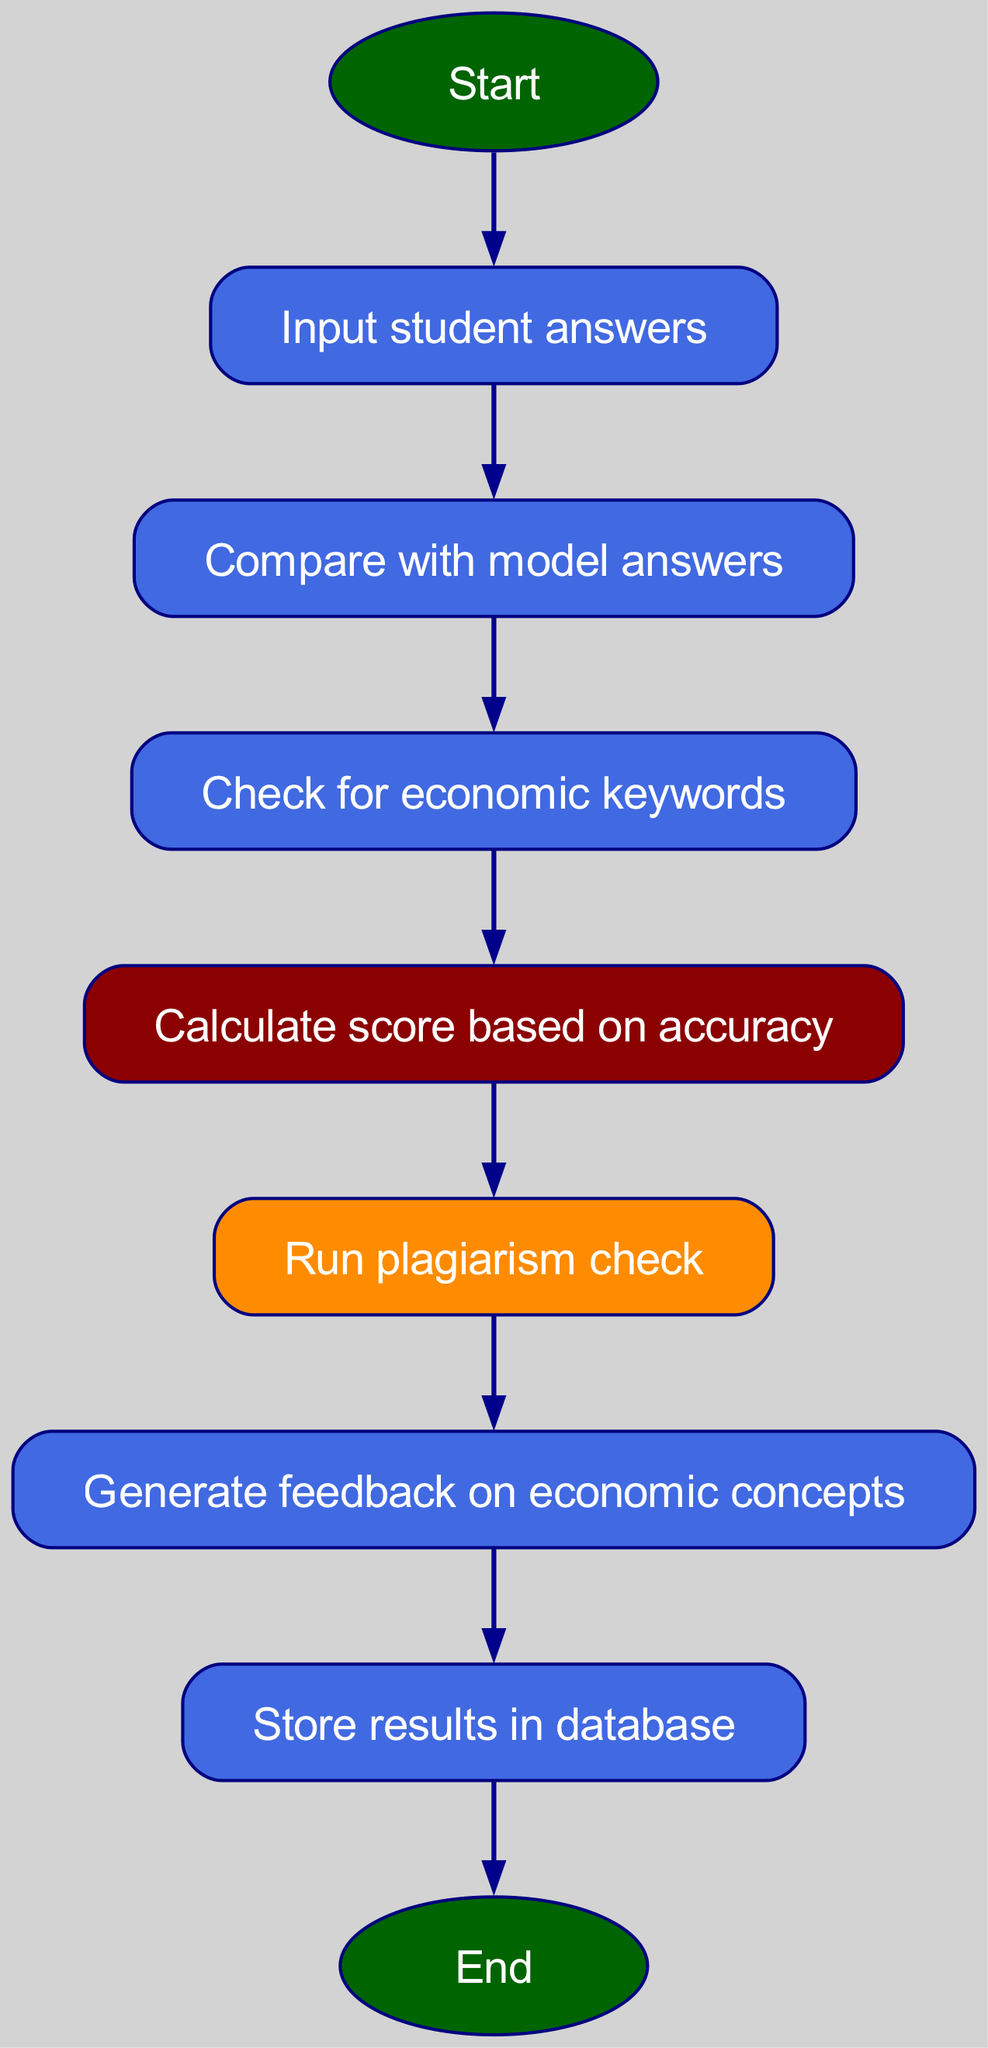What is the first step in the flowchart? The first step in the flowchart is labeled 'Start'. This begins the entire automated grading process, making it the initial node in the diagram.
Answer: Start How many nodes are present in the diagram? By counting the individual nodes listed, we find there are a total of 9 nodes, including 'Start' and 'End'. Each distinct step in the grading process is represented as a separate node.
Answer: 9 What is the final action taken in this flowchart? The final action is 'End', which indicates the completion of the automated grading process. This node signifies that all preceding steps have been concluded.
Answer: End What step follows after "Check for economic keywords"? The step that follows is "Calculate score based on accuracy". This indicates that after economic keywords have been checked, the system will proceed to scoring.
Answer: Calculate score based on accuracy Which step involves storing results? The step that involves storing results is "Store results in database". This indicates that after feedback has been generated, the outcomes will be saved for further reference or analysis.
Answer: Store results in database What is the purpose of the "Run plagiarism check" step? The purpose of this step is to ensure that the submitted student answers do not contain plagiarized content. It serves as a quality control step in the grading process to maintain academic integrity.
Answer: Ensure academic integrity How do you move from the "Input student answers" node to the "Compare with model answers" node? To move from the "Input student answers" node to the "Compare with model answers" node, the flowchart indicates a direct edge connecting these two nodes, illustrating the progression of the grading process.
Answer: Direct edge What actions are performed after calculating the score? After calculating the score, the next action is to 'Run plagiarism check'. This indicates a sequential dependency where scoring must occur before assessing the originality of the answers.
Answer: Run plagiarism check What is depicted in the flow of 'Generate feedback on economic concepts'? This step shows that after running a plagiarism check, feedback regarding the economic concepts addressed in the answers will be generated, indicating a focus on providing constructive criticism.
Answer: Generate feedback on economic concepts 